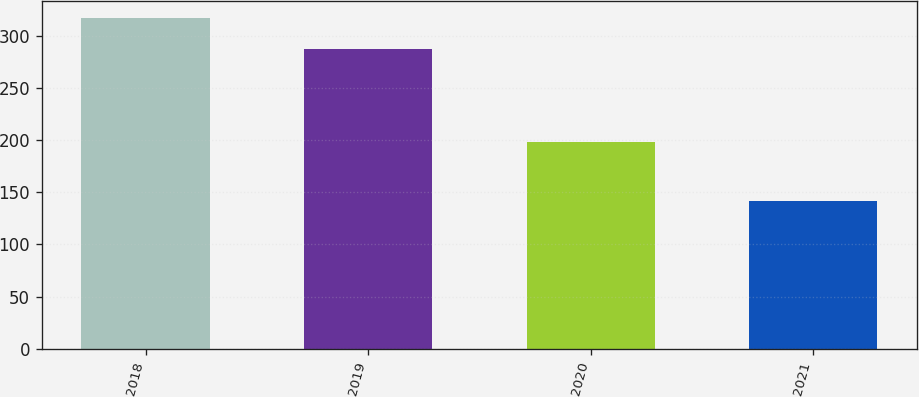Convert chart to OTSL. <chart><loc_0><loc_0><loc_500><loc_500><bar_chart><fcel>2018<fcel>2019<fcel>2020<fcel>2021<nl><fcel>318<fcel>288<fcel>198<fcel>142<nl></chart> 